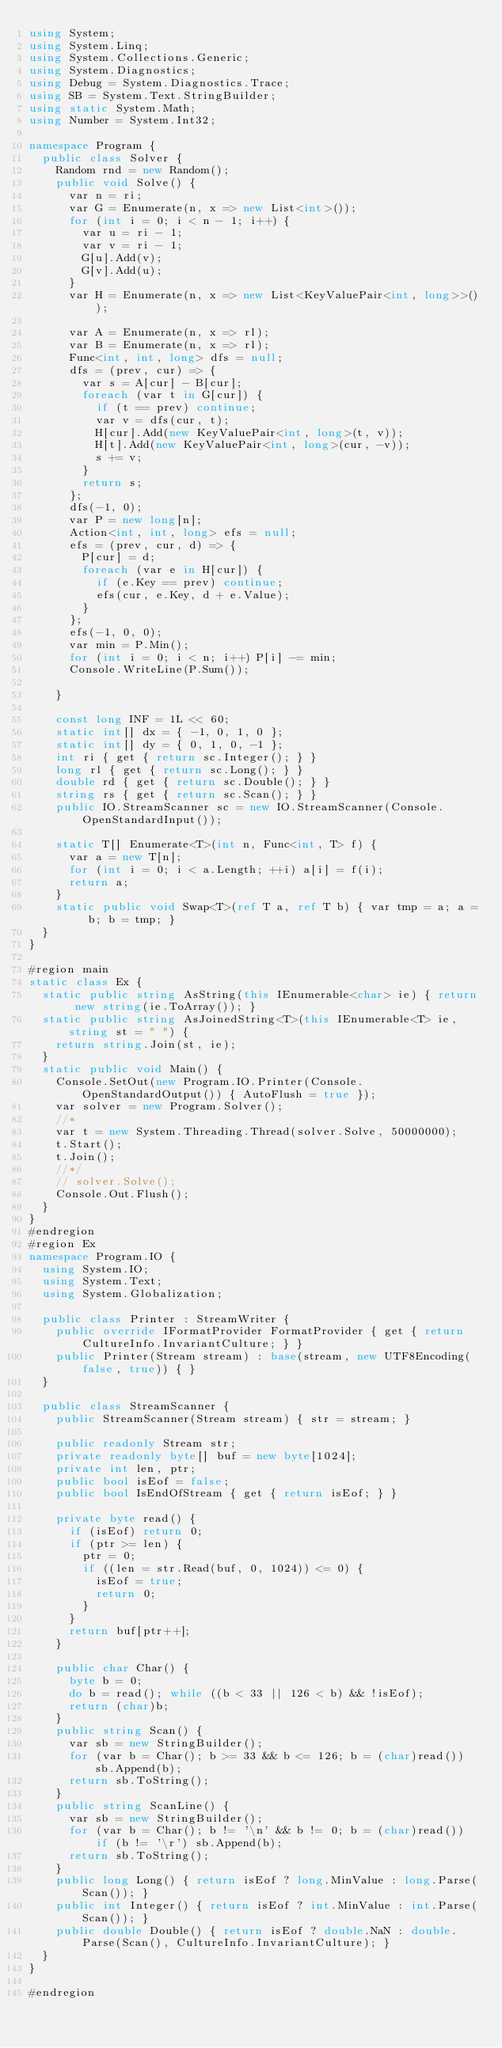<code> <loc_0><loc_0><loc_500><loc_500><_C#_>using System;
using System.Linq;
using System.Collections.Generic;
using System.Diagnostics;
using Debug = System.Diagnostics.Trace;
using SB = System.Text.StringBuilder;
using static System.Math;
using Number = System.Int32;

namespace Program {
	public class Solver {
		Random rnd = new Random();
		public void Solve() {
			var n = ri;
			var G = Enumerate(n, x => new List<int>());
			for (int i = 0; i < n - 1; i++) {
				var u = ri - 1;
				var v = ri - 1;
				G[u].Add(v);
				G[v].Add(u);
			}
			var H = Enumerate(n, x => new List<KeyValuePair<int, long>>());

			var A = Enumerate(n, x => rl);
			var B = Enumerate(n, x => rl);
			Func<int, int, long> dfs = null;
			dfs = (prev, cur) => {
				var s = A[cur] - B[cur];
				foreach (var t in G[cur]) {
					if (t == prev) continue;
					var v = dfs(cur, t);
					H[cur].Add(new KeyValuePair<int, long>(t, v));
					H[t].Add(new KeyValuePair<int, long>(cur, -v));
					s += v;
				}
				return s;
			};
			dfs(-1, 0);
			var P = new long[n];
			Action<int, int, long> efs = null;
			efs = (prev, cur, d) => {
				P[cur] = d;
				foreach (var e in H[cur]) {
					if (e.Key == prev) continue;
					efs(cur, e.Key, d + e.Value);
				}
			};
			efs(-1, 0, 0);
			var min = P.Min();
			for (int i = 0; i < n; i++) P[i] -= min;
			Console.WriteLine(P.Sum());

		}

		const long INF = 1L << 60;
		static int[] dx = { -1, 0, 1, 0 };
		static int[] dy = { 0, 1, 0, -1 };
		int ri { get { return sc.Integer(); } }
		long rl { get { return sc.Long(); } }
		double rd { get { return sc.Double(); } }
		string rs { get { return sc.Scan(); } }
		public IO.StreamScanner sc = new IO.StreamScanner(Console.OpenStandardInput());

		static T[] Enumerate<T>(int n, Func<int, T> f) {
			var a = new T[n];
			for (int i = 0; i < a.Length; ++i) a[i] = f(i);
			return a;
		}
		static public void Swap<T>(ref T a, ref T b) { var tmp = a; a = b; b = tmp; }
	}
}

#region main
static class Ex {
	static public string AsString(this IEnumerable<char> ie) { return new string(ie.ToArray()); }
	static public string AsJoinedString<T>(this IEnumerable<T> ie, string st = " ") {
		return string.Join(st, ie);
	}
	static public void Main() {
		Console.SetOut(new Program.IO.Printer(Console.OpenStandardOutput()) { AutoFlush = true });
		var solver = new Program.Solver();
		//* 
		var t = new System.Threading.Thread(solver.Solve, 50000000);
		t.Start();
		t.Join();
		//*/
		// solver.Solve();
		Console.Out.Flush();
	}
}
#endregion
#region Ex
namespace Program.IO {
	using System.IO;
	using System.Text;
	using System.Globalization;

	public class Printer : StreamWriter {
		public override IFormatProvider FormatProvider { get { return CultureInfo.InvariantCulture; } }
		public Printer(Stream stream) : base(stream, new UTF8Encoding(false, true)) { }
	}

	public class StreamScanner {
		public StreamScanner(Stream stream) { str = stream; }

		public readonly Stream str;
		private readonly byte[] buf = new byte[1024];
		private int len, ptr;
		public bool isEof = false;
		public bool IsEndOfStream { get { return isEof; } }

		private byte read() {
			if (isEof) return 0;
			if (ptr >= len) {
				ptr = 0;
				if ((len = str.Read(buf, 0, 1024)) <= 0) {
					isEof = true;
					return 0;
				}
			}
			return buf[ptr++];
		}

		public char Char() {
			byte b = 0;
			do b = read(); while ((b < 33 || 126 < b) && !isEof);
			return (char)b;
		}
		public string Scan() {
			var sb = new StringBuilder();
			for (var b = Char(); b >= 33 && b <= 126; b = (char)read()) sb.Append(b);
			return sb.ToString();
		}
		public string ScanLine() {
			var sb = new StringBuilder();
			for (var b = Char(); b != '\n' && b != 0; b = (char)read()) if (b != '\r') sb.Append(b);
			return sb.ToString();
		}
		public long Long() { return isEof ? long.MinValue : long.Parse(Scan()); }
		public int Integer() { return isEof ? int.MinValue : int.Parse(Scan()); }
		public double Double() { return isEof ? double.NaN : double.Parse(Scan(), CultureInfo.InvariantCulture); }
	}
}

#endregion

</code> 